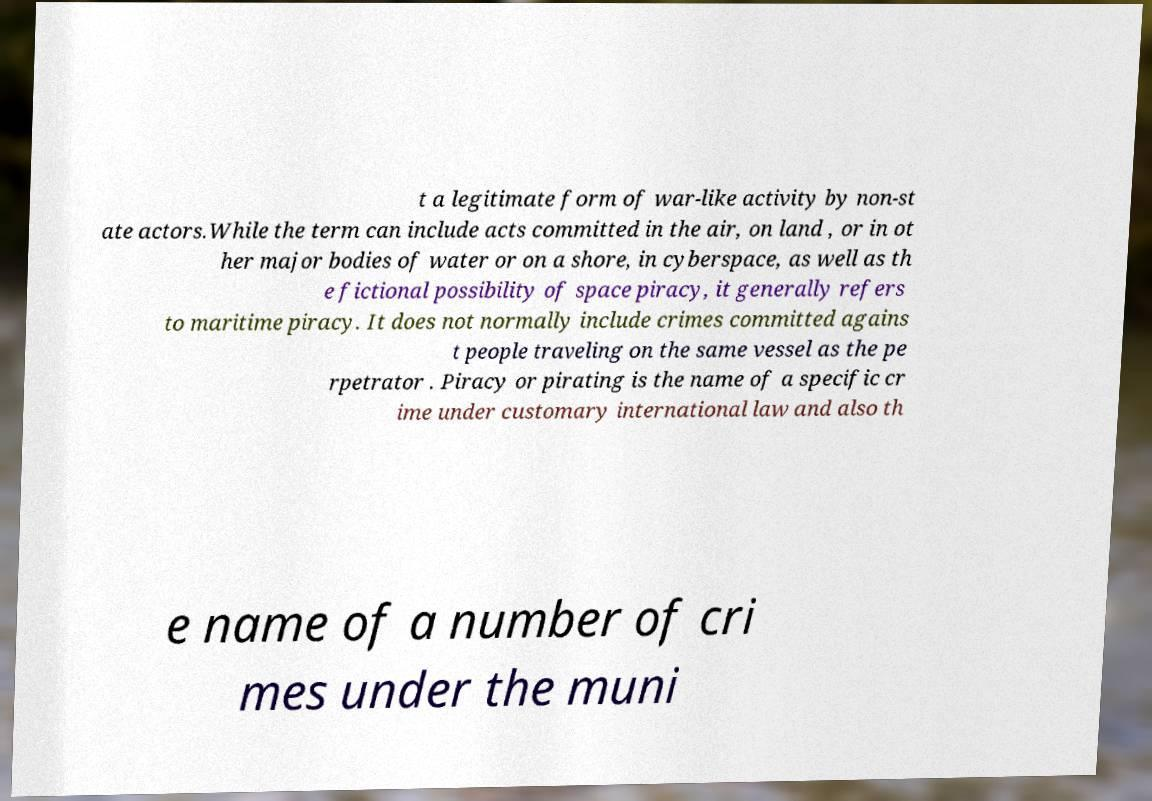Can you read and provide the text displayed in the image?This photo seems to have some interesting text. Can you extract and type it out for me? t a legitimate form of war-like activity by non-st ate actors.While the term can include acts committed in the air, on land , or in ot her major bodies of water or on a shore, in cyberspace, as well as th e fictional possibility of space piracy, it generally refers to maritime piracy. It does not normally include crimes committed agains t people traveling on the same vessel as the pe rpetrator . Piracy or pirating is the name of a specific cr ime under customary international law and also th e name of a number of cri mes under the muni 